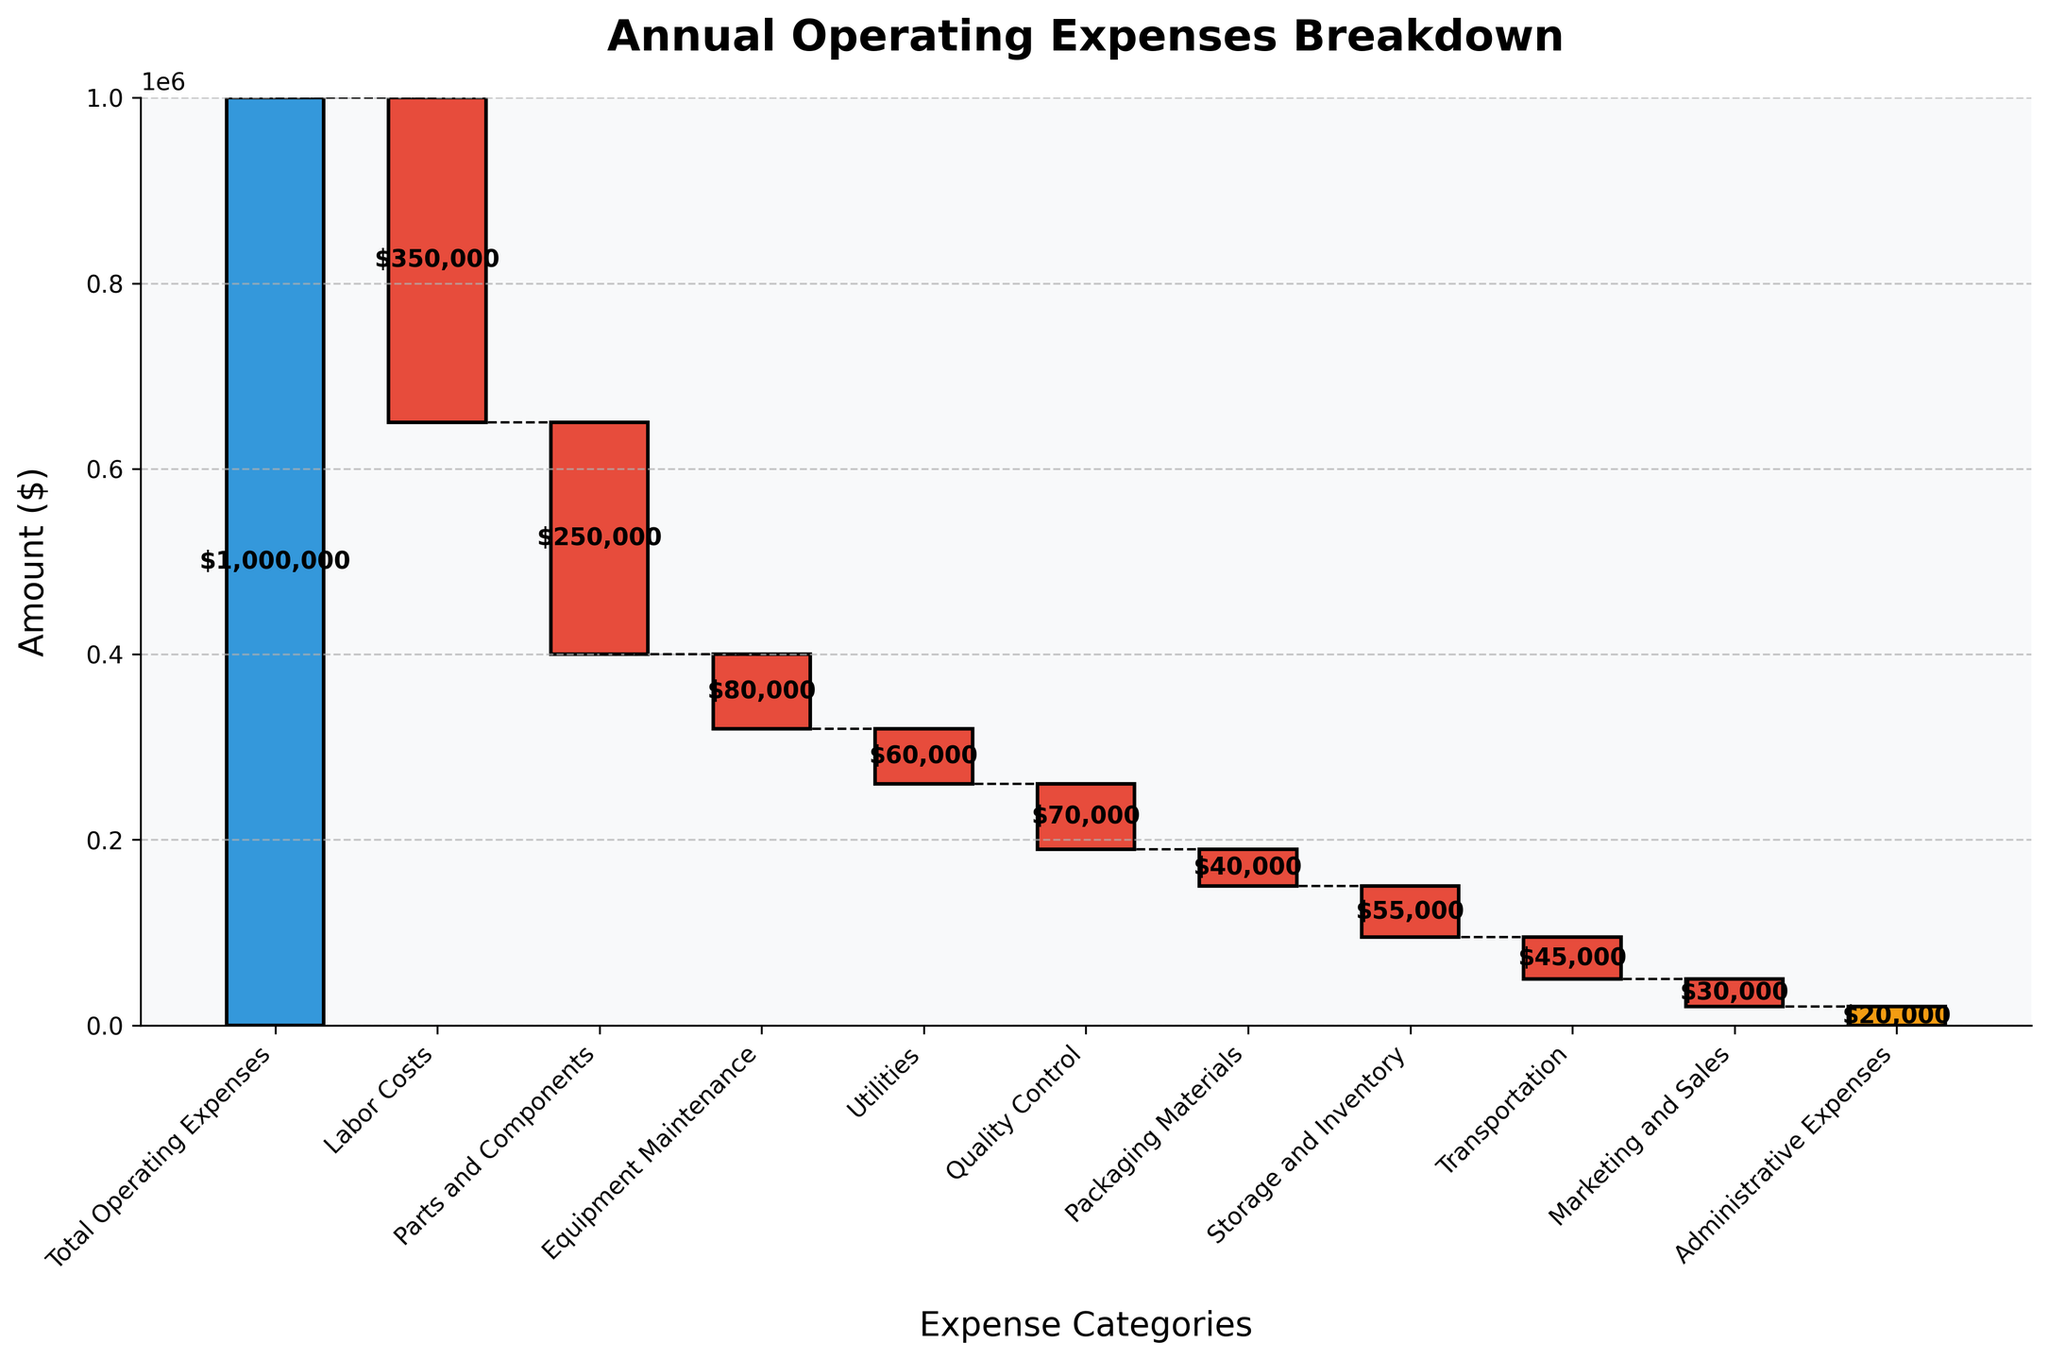What is the total operating expense according to the figure? The total operating expense is shown as the starting value in the Waterfall Chart, represented by the first bar, labeled "Total Operating Expenses."
Answer: $1,000,000 Which expense category has the highest cost? By visually examining the Waterfall Chart, the category with the deepest negative drop is "Labor Costs," making it the highest cost category.
Answer: Labor Costs How much are the parts and components expenses? The expense for "Parts and Components" is identified by the bar labeled with that category, which shows a drop in value. The label on the bar indicates the expense amount.
Answer: $250,000 What is the difference between Equipment Maintenance and Utilities expenses? To find the difference, look at the values beside each category: Equipment Maintenance ($80,000) and Utilities ($60,000). Subtract the Utilities cost from the Equipment Maintenance cost.
Answer: $20,000 Which category contributes the least to the operating expenses? Identify the smallest bar representing negative values. By comparing bars, "Administrative Expenses" shows the smallest decrease among all categories.
Answer: Administrative Expenses Are labor costs more than double the utilities costs? Calculate double the Utilities expense ($60,000 * 2 = $120,000) and compare it with the Labor Costs ($350,000). Since $350,000 is significantly higher than $120,000, it's clear that Labor Costs are more than double.
Answer: Yes What are the cumulative operating expenses after accounting for Equipment Maintenance costs? Start from the total operating expenses ($1,000,000), subtract Labor Costs, Parts and Components, then Equipment Maintenance. Calculation: $1,000,000 - $350,000 - $250,000 - $80,000 = $320,000
Answer: $320,000 How much more are Quality Control expenses compared to Packaging Materials expenses? Compare the values of "Quality Control" ($70,000) and "Packaging Materials" ($40,000) by subtraction: $70,000 - $40,000 = $30,000.
Answer: $30,000 List the expenses greater than $50,000 in descending order. Identify and order the expenses: Labor Costs ($350,000), Parts and Components ($250,000), Equipment Maintenance ($80,000), Quality Control ($70,000), Storage and Inventory ($55,000).
Answer: Labor Costs, Parts and Components, Equipment Maintenance, Quality Control, Storage and Inventory 